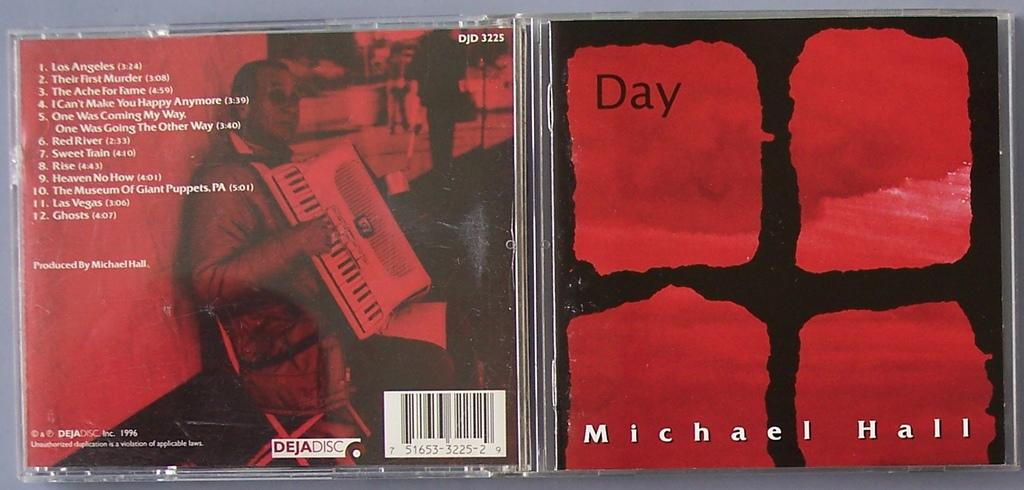Provide a one-sentence caption for the provided image. The front and back cover of Michael Hall's  Day CD has a deep red background. 